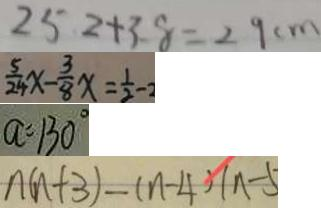<formula> <loc_0><loc_0><loc_500><loc_500>2 5 . 2 + 3 . 8 = 2 9 c m 
 \frac { 5 } { 2 4 } x - \frac { 3 } { 8 } x = \frac { 1 } { 2 } - 2 
 a = 1 3 0 ^ { \circ } 
 n ( n + 3 ) - ( n - 4 ) ( n - 5</formula> 